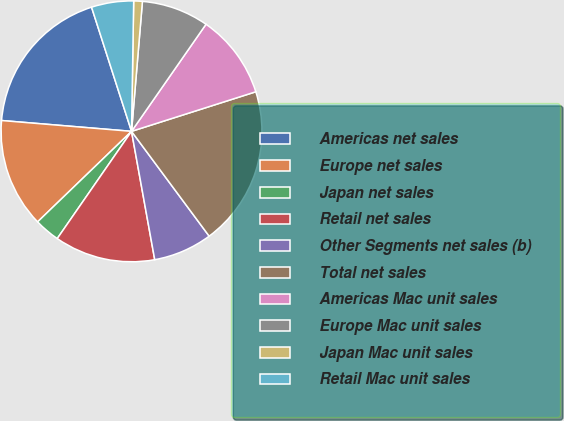Convert chart to OTSL. <chart><loc_0><loc_0><loc_500><loc_500><pie_chart><fcel>Americas net sales<fcel>Europe net sales<fcel>Japan net sales<fcel>Retail net sales<fcel>Other Segments net sales (b)<fcel>Total net sales<fcel>Americas Mac unit sales<fcel>Europe Mac unit sales<fcel>Japan Mac unit sales<fcel>Retail Mac unit sales<nl><fcel>18.72%<fcel>13.53%<fcel>3.15%<fcel>12.49%<fcel>7.3%<fcel>19.76%<fcel>10.42%<fcel>8.34%<fcel>1.07%<fcel>5.22%<nl></chart> 